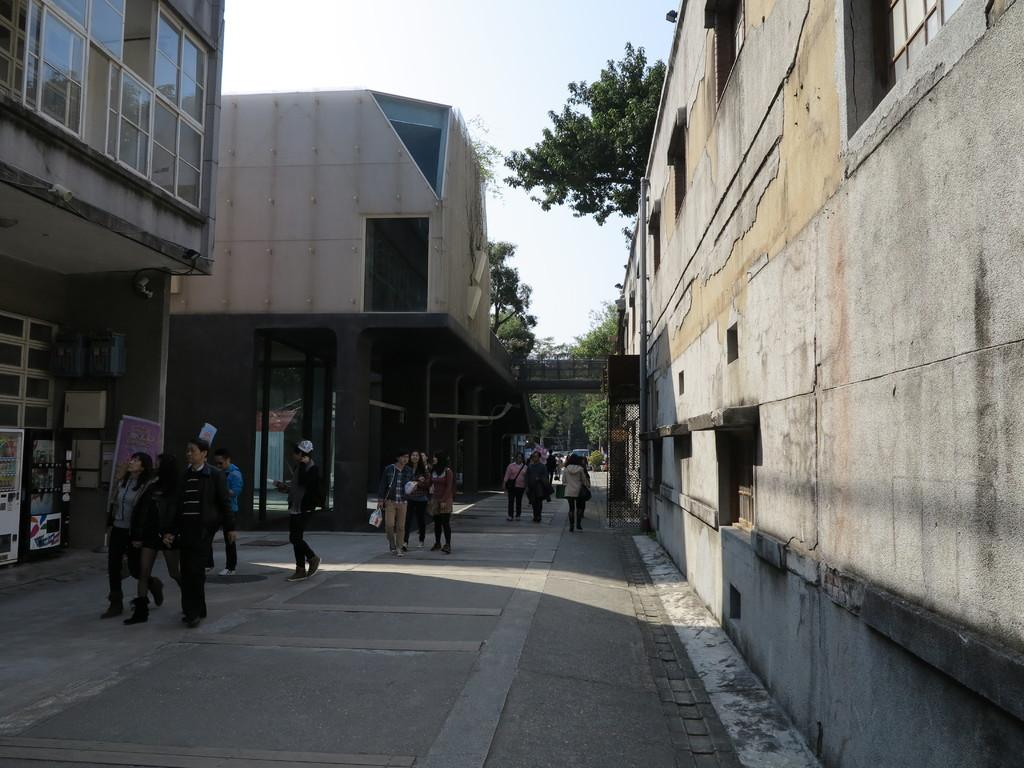What is happening on the ground in the image? There are people on the ground in the image. What can be seen in the background of the image? Buildings and the sky are visible in the background of the image. What type of vegetation is present in the image? Trees are present in the image. What other objects can be seen on the ground in the image? There are other objects on the ground in the image. What type of popcorn is being served to the people in the image? There is no popcorn present in the image. How many houses are visible in the image? The image does not show any houses; it only shows buildings. 